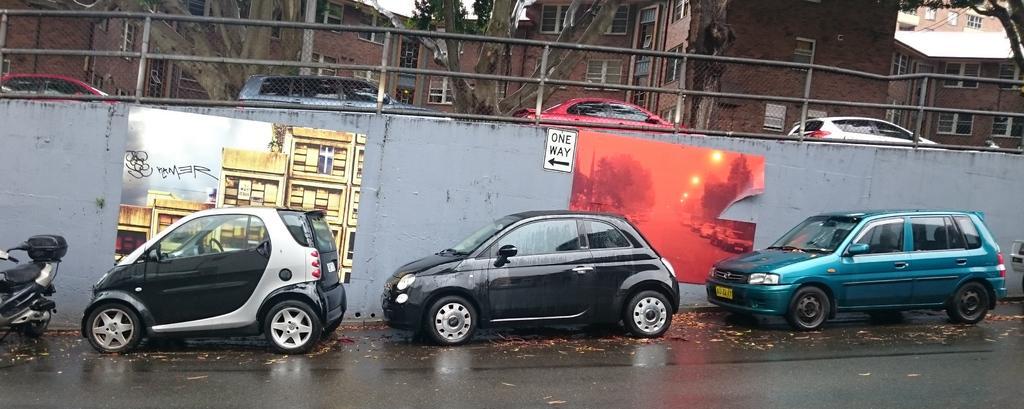Describe this image in one or two sentences. This picture is clicked outside the city. At the bottom of the picture, there are cars and a bike parked on the road. Beside that, we see cars moving on the bridge. There are trees and buildings in the background. 